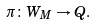Convert formula to latex. <formula><loc_0><loc_0><loc_500><loc_500>\pi \colon W _ { M } \to Q .</formula> 